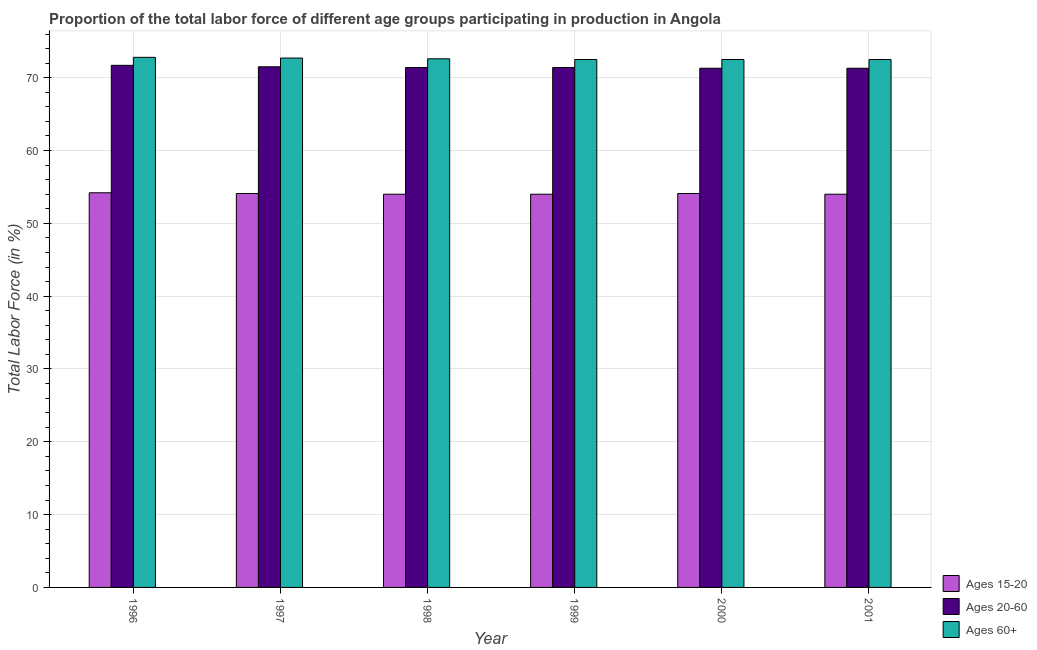How many groups of bars are there?
Give a very brief answer. 6. Are the number of bars per tick equal to the number of legend labels?
Your response must be concise. Yes. Are the number of bars on each tick of the X-axis equal?
Make the answer very short. Yes. How many bars are there on the 4th tick from the right?
Your response must be concise. 3. In how many cases, is the number of bars for a given year not equal to the number of legend labels?
Ensure brevity in your answer.  0. Across all years, what is the maximum percentage of labor force within the age group 15-20?
Offer a terse response. 54.2. Across all years, what is the minimum percentage of labor force within the age group 20-60?
Your answer should be very brief. 71.3. In which year was the percentage of labor force within the age group 20-60 minimum?
Offer a very short reply. 2000. What is the total percentage of labor force above age 60 in the graph?
Provide a short and direct response. 435.6. What is the difference between the percentage of labor force within the age group 15-20 in 1996 and that in 1998?
Your answer should be very brief. 0.2. What is the difference between the percentage of labor force above age 60 in 2000 and the percentage of labor force within the age group 20-60 in 1996?
Provide a short and direct response. -0.3. What is the average percentage of labor force above age 60 per year?
Provide a succinct answer. 72.6. In how many years, is the percentage of labor force within the age group 15-20 greater than 26 %?
Your answer should be compact. 6. What is the ratio of the percentage of labor force within the age group 20-60 in 1996 to that in 1997?
Offer a very short reply. 1. Is the percentage of labor force above age 60 in 1998 less than that in 2000?
Your answer should be very brief. No. Is the difference between the percentage of labor force above age 60 in 1996 and 1997 greater than the difference between the percentage of labor force within the age group 15-20 in 1996 and 1997?
Make the answer very short. No. What is the difference between the highest and the second highest percentage of labor force within the age group 20-60?
Give a very brief answer. 0.2. What is the difference between the highest and the lowest percentage of labor force within the age group 15-20?
Your answer should be compact. 0.2. In how many years, is the percentage of labor force within the age group 20-60 greater than the average percentage of labor force within the age group 20-60 taken over all years?
Offer a very short reply. 2. Is the sum of the percentage of labor force above age 60 in 1997 and 1998 greater than the maximum percentage of labor force within the age group 20-60 across all years?
Provide a short and direct response. Yes. What does the 1st bar from the left in 1999 represents?
Ensure brevity in your answer.  Ages 15-20. What does the 3rd bar from the right in 1997 represents?
Provide a short and direct response. Ages 15-20. How many bars are there?
Your answer should be compact. 18. How many years are there in the graph?
Your response must be concise. 6. Are the values on the major ticks of Y-axis written in scientific E-notation?
Offer a terse response. No. Does the graph contain grids?
Your answer should be compact. Yes. Where does the legend appear in the graph?
Provide a succinct answer. Bottom right. What is the title of the graph?
Make the answer very short. Proportion of the total labor force of different age groups participating in production in Angola. Does "Fuel" appear as one of the legend labels in the graph?
Your answer should be very brief. No. What is the Total Labor Force (in %) in Ages 15-20 in 1996?
Make the answer very short. 54.2. What is the Total Labor Force (in %) of Ages 20-60 in 1996?
Your response must be concise. 71.7. What is the Total Labor Force (in %) of Ages 60+ in 1996?
Keep it short and to the point. 72.8. What is the Total Labor Force (in %) of Ages 15-20 in 1997?
Your answer should be very brief. 54.1. What is the Total Labor Force (in %) in Ages 20-60 in 1997?
Offer a very short reply. 71.5. What is the Total Labor Force (in %) of Ages 60+ in 1997?
Provide a succinct answer. 72.7. What is the Total Labor Force (in %) of Ages 15-20 in 1998?
Provide a short and direct response. 54. What is the Total Labor Force (in %) of Ages 20-60 in 1998?
Your answer should be compact. 71.4. What is the Total Labor Force (in %) in Ages 60+ in 1998?
Provide a succinct answer. 72.6. What is the Total Labor Force (in %) of Ages 15-20 in 1999?
Ensure brevity in your answer.  54. What is the Total Labor Force (in %) in Ages 20-60 in 1999?
Keep it short and to the point. 71.4. What is the Total Labor Force (in %) of Ages 60+ in 1999?
Your response must be concise. 72.5. What is the Total Labor Force (in %) of Ages 15-20 in 2000?
Give a very brief answer. 54.1. What is the Total Labor Force (in %) in Ages 20-60 in 2000?
Ensure brevity in your answer.  71.3. What is the Total Labor Force (in %) in Ages 60+ in 2000?
Your answer should be compact. 72.5. What is the Total Labor Force (in %) of Ages 20-60 in 2001?
Provide a succinct answer. 71.3. What is the Total Labor Force (in %) in Ages 60+ in 2001?
Provide a succinct answer. 72.5. Across all years, what is the maximum Total Labor Force (in %) in Ages 15-20?
Give a very brief answer. 54.2. Across all years, what is the maximum Total Labor Force (in %) of Ages 20-60?
Offer a very short reply. 71.7. Across all years, what is the maximum Total Labor Force (in %) in Ages 60+?
Keep it short and to the point. 72.8. Across all years, what is the minimum Total Labor Force (in %) of Ages 15-20?
Offer a very short reply. 54. Across all years, what is the minimum Total Labor Force (in %) in Ages 20-60?
Your answer should be compact. 71.3. Across all years, what is the minimum Total Labor Force (in %) in Ages 60+?
Ensure brevity in your answer.  72.5. What is the total Total Labor Force (in %) of Ages 15-20 in the graph?
Ensure brevity in your answer.  324.4. What is the total Total Labor Force (in %) in Ages 20-60 in the graph?
Your answer should be very brief. 428.6. What is the total Total Labor Force (in %) in Ages 60+ in the graph?
Your response must be concise. 435.6. What is the difference between the Total Labor Force (in %) of Ages 15-20 in 1996 and that in 1997?
Your answer should be very brief. 0.1. What is the difference between the Total Labor Force (in %) of Ages 20-60 in 1996 and that in 1997?
Your response must be concise. 0.2. What is the difference between the Total Labor Force (in %) in Ages 15-20 in 1996 and that in 1998?
Ensure brevity in your answer.  0.2. What is the difference between the Total Labor Force (in %) of Ages 20-60 in 1996 and that in 1998?
Offer a terse response. 0.3. What is the difference between the Total Labor Force (in %) of Ages 20-60 in 1996 and that in 1999?
Offer a very short reply. 0.3. What is the difference between the Total Labor Force (in %) of Ages 60+ in 1996 and that in 1999?
Provide a succinct answer. 0.3. What is the difference between the Total Labor Force (in %) of Ages 15-20 in 1996 and that in 2000?
Make the answer very short. 0.1. What is the difference between the Total Labor Force (in %) in Ages 15-20 in 1996 and that in 2001?
Provide a succinct answer. 0.2. What is the difference between the Total Labor Force (in %) in Ages 20-60 in 1996 and that in 2001?
Make the answer very short. 0.4. What is the difference between the Total Labor Force (in %) of Ages 60+ in 1996 and that in 2001?
Provide a short and direct response. 0.3. What is the difference between the Total Labor Force (in %) of Ages 20-60 in 1997 and that in 1998?
Your response must be concise. 0.1. What is the difference between the Total Labor Force (in %) of Ages 20-60 in 1997 and that in 1999?
Give a very brief answer. 0.1. What is the difference between the Total Labor Force (in %) in Ages 20-60 in 1997 and that in 2001?
Provide a short and direct response. 0.2. What is the difference between the Total Labor Force (in %) of Ages 60+ in 1997 and that in 2001?
Offer a terse response. 0.2. What is the difference between the Total Labor Force (in %) in Ages 60+ in 1998 and that in 1999?
Provide a short and direct response. 0.1. What is the difference between the Total Labor Force (in %) of Ages 20-60 in 1998 and that in 2000?
Keep it short and to the point. 0.1. What is the difference between the Total Labor Force (in %) of Ages 20-60 in 1998 and that in 2001?
Your answer should be compact. 0.1. What is the difference between the Total Labor Force (in %) of Ages 15-20 in 1999 and that in 2000?
Give a very brief answer. -0.1. What is the difference between the Total Labor Force (in %) of Ages 20-60 in 1999 and that in 2000?
Give a very brief answer. 0.1. What is the difference between the Total Labor Force (in %) of Ages 60+ in 1999 and that in 2000?
Offer a very short reply. 0. What is the difference between the Total Labor Force (in %) of Ages 60+ in 2000 and that in 2001?
Offer a terse response. 0. What is the difference between the Total Labor Force (in %) in Ages 15-20 in 1996 and the Total Labor Force (in %) in Ages 20-60 in 1997?
Provide a short and direct response. -17.3. What is the difference between the Total Labor Force (in %) in Ages 15-20 in 1996 and the Total Labor Force (in %) in Ages 60+ in 1997?
Give a very brief answer. -18.5. What is the difference between the Total Labor Force (in %) of Ages 20-60 in 1996 and the Total Labor Force (in %) of Ages 60+ in 1997?
Keep it short and to the point. -1. What is the difference between the Total Labor Force (in %) of Ages 15-20 in 1996 and the Total Labor Force (in %) of Ages 20-60 in 1998?
Offer a terse response. -17.2. What is the difference between the Total Labor Force (in %) in Ages 15-20 in 1996 and the Total Labor Force (in %) in Ages 60+ in 1998?
Offer a very short reply. -18.4. What is the difference between the Total Labor Force (in %) in Ages 15-20 in 1996 and the Total Labor Force (in %) in Ages 20-60 in 1999?
Provide a succinct answer. -17.2. What is the difference between the Total Labor Force (in %) in Ages 15-20 in 1996 and the Total Labor Force (in %) in Ages 60+ in 1999?
Provide a short and direct response. -18.3. What is the difference between the Total Labor Force (in %) of Ages 15-20 in 1996 and the Total Labor Force (in %) of Ages 20-60 in 2000?
Offer a very short reply. -17.1. What is the difference between the Total Labor Force (in %) in Ages 15-20 in 1996 and the Total Labor Force (in %) in Ages 60+ in 2000?
Ensure brevity in your answer.  -18.3. What is the difference between the Total Labor Force (in %) of Ages 20-60 in 1996 and the Total Labor Force (in %) of Ages 60+ in 2000?
Offer a terse response. -0.8. What is the difference between the Total Labor Force (in %) in Ages 15-20 in 1996 and the Total Labor Force (in %) in Ages 20-60 in 2001?
Offer a terse response. -17.1. What is the difference between the Total Labor Force (in %) in Ages 15-20 in 1996 and the Total Labor Force (in %) in Ages 60+ in 2001?
Your answer should be compact. -18.3. What is the difference between the Total Labor Force (in %) in Ages 20-60 in 1996 and the Total Labor Force (in %) in Ages 60+ in 2001?
Your response must be concise. -0.8. What is the difference between the Total Labor Force (in %) of Ages 15-20 in 1997 and the Total Labor Force (in %) of Ages 20-60 in 1998?
Make the answer very short. -17.3. What is the difference between the Total Labor Force (in %) of Ages 15-20 in 1997 and the Total Labor Force (in %) of Ages 60+ in 1998?
Provide a short and direct response. -18.5. What is the difference between the Total Labor Force (in %) of Ages 15-20 in 1997 and the Total Labor Force (in %) of Ages 20-60 in 1999?
Offer a terse response. -17.3. What is the difference between the Total Labor Force (in %) of Ages 15-20 in 1997 and the Total Labor Force (in %) of Ages 60+ in 1999?
Keep it short and to the point. -18.4. What is the difference between the Total Labor Force (in %) in Ages 20-60 in 1997 and the Total Labor Force (in %) in Ages 60+ in 1999?
Your answer should be compact. -1. What is the difference between the Total Labor Force (in %) of Ages 15-20 in 1997 and the Total Labor Force (in %) of Ages 20-60 in 2000?
Make the answer very short. -17.2. What is the difference between the Total Labor Force (in %) in Ages 15-20 in 1997 and the Total Labor Force (in %) in Ages 60+ in 2000?
Your response must be concise. -18.4. What is the difference between the Total Labor Force (in %) in Ages 20-60 in 1997 and the Total Labor Force (in %) in Ages 60+ in 2000?
Your response must be concise. -1. What is the difference between the Total Labor Force (in %) in Ages 15-20 in 1997 and the Total Labor Force (in %) in Ages 20-60 in 2001?
Give a very brief answer. -17.2. What is the difference between the Total Labor Force (in %) in Ages 15-20 in 1997 and the Total Labor Force (in %) in Ages 60+ in 2001?
Your answer should be compact. -18.4. What is the difference between the Total Labor Force (in %) of Ages 20-60 in 1997 and the Total Labor Force (in %) of Ages 60+ in 2001?
Your answer should be compact. -1. What is the difference between the Total Labor Force (in %) of Ages 15-20 in 1998 and the Total Labor Force (in %) of Ages 20-60 in 1999?
Ensure brevity in your answer.  -17.4. What is the difference between the Total Labor Force (in %) in Ages 15-20 in 1998 and the Total Labor Force (in %) in Ages 60+ in 1999?
Your response must be concise. -18.5. What is the difference between the Total Labor Force (in %) of Ages 15-20 in 1998 and the Total Labor Force (in %) of Ages 20-60 in 2000?
Offer a terse response. -17.3. What is the difference between the Total Labor Force (in %) in Ages 15-20 in 1998 and the Total Labor Force (in %) in Ages 60+ in 2000?
Your answer should be compact. -18.5. What is the difference between the Total Labor Force (in %) of Ages 20-60 in 1998 and the Total Labor Force (in %) of Ages 60+ in 2000?
Your answer should be compact. -1.1. What is the difference between the Total Labor Force (in %) of Ages 15-20 in 1998 and the Total Labor Force (in %) of Ages 20-60 in 2001?
Your answer should be very brief. -17.3. What is the difference between the Total Labor Force (in %) of Ages 15-20 in 1998 and the Total Labor Force (in %) of Ages 60+ in 2001?
Offer a very short reply. -18.5. What is the difference between the Total Labor Force (in %) in Ages 20-60 in 1998 and the Total Labor Force (in %) in Ages 60+ in 2001?
Provide a succinct answer. -1.1. What is the difference between the Total Labor Force (in %) in Ages 15-20 in 1999 and the Total Labor Force (in %) in Ages 20-60 in 2000?
Your response must be concise. -17.3. What is the difference between the Total Labor Force (in %) in Ages 15-20 in 1999 and the Total Labor Force (in %) in Ages 60+ in 2000?
Provide a short and direct response. -18.5. What is the difference between the Total Labor Force (in %) in Ages 15-20 in 1999 and the Total Labor Force (in %) in Ages 20-60 in 2001?
Keep it short and to the point. -17.3. What is the difference between the Total Labor Force (in %) in Ages 15-20 in 1999 and the Total Labor Force (in %) in Ages 60+ in 2001?
Offer a terse response. -18.5. What is the difference between the Total Labor Force (in %) of Ages 15-20 in 2000 and the Total Labor Force (in %) of Ages 20-60 in 2001?
Offer a terse response. -17.2. What is the difference between the Total Labor Force (in %) of Ages 15-20 in 2000 and the Total Labor Force (in %) of Ages 60+ in 2001?
Offer a very short reply. -18.4. What is the difference between the Total Labor Force (in %) of Ages 20-60 in 2000 and the Total Labor Force (in %) of Ages 60+ in 2001?
Give a very brief answer. -1.2. What is the average Total Labor Force (in %) of Ages 15-20 per year?
Keep it short and to the point. 54.07. What is the average Total Labor Force (in %) of Ages 20-60 per year?
Your answer should be compact. 71.43. What is the average Total Labor Force (in %) in Ages 60+ per year?
Make the answer very short. 72.6. In the year 1996, what is the difference between the Total Labor Force (in %) in Ages 15-20 and Total Labor Force (in %) in Ages 20-60?
Provide a short and direct response. -17.5. In the year 1996, what is the difference between the Total Labor Force (in %) in Ages 15-20 and Total Labor Force (in %) in Ages 60+?
Offer a terse response. -18.6. In the year 1997, what is the difference between the Total Labor Force (in %) of Ages 15-20 and Total Labor Force (in %) of Ages 20-60?
Give a very brief answer. -17.4. In the year 1997, what is the difference between the Total Labor Force (in %) of Ages 15-20 and Total Labor Force (in %) of Ages 60+?
Your response must be concise. -18.6. In the year 1998, what is the difference between the Total Labor Force (in %) of Ages 15-20 and Total Labor Force (in %) of Ages 20-60?
Offer a very short reply. -17.4. In the year 1998, what is the difference between the Total Labor Force (in %) of Ages 15-20 and Total Labor Force (in %) of Ages 60+?
Ensure brevity in your answer.  -18.6. In the year 1999, what is the difference between the Total Labor Force (in %) of Ages 15-20 and Total Labor Force (in %) of Ages 20-60?
Your answer should be very brief. -17.4. In the year 1999, what is the difference between the Total Labor Force (in %) of Ages 15-20 and Total Labor Force (in %) of Ages 60+?
Your response must be concise. -18.5. In the year 1999, what is the difference between the Total Labor Force (in %) of Ages 20-60 and Total Labor Force (in %) of Ages 60+?
Your answer should be very brief. -1.1. In the year 2000, what is the difference between the Total Labor Force (in %) of Ages 15-20 and Total Labor Force (in %) of Ages 20-60?
Make the answer very short. -17.2. In the year 2000, what is the difference between the Total Labor Force (in %) of Ages 15-20 and Total Labor Force (in %) of Ages 60+?
Keep it short and to the point. -18.4. In the year 2000, what is the difference between the Total Labor Force (in %) of Ages 20-60 and Total Labor Force (in %) of Ages 60+?
Your answer should be compact. -1.2. In the year 2001, what is the difference between the Total Labor Force (in %) of Ages 15-20 and Total Labor Force (in %) of Ages 20-60?
Provide a short and direct response. -17.3. In the year 2001, what is the difference between the Total Labor Force (in %) of Ages 15-20 and Total Labor Force (in %) of Ages 60+?
Your answer should be compact. -18.5. In the year 2001, what is the difference between the Total Labor Force (in %) of Ages 20-60 and Total Labor Force (in %) of Ages 60+?
Provide a succinct answer. -1.2. What is the ratio of the Total Labor Force (in %) of Ages 15-20 in 1996 to that in 1997?
Your answer should be compact. 1. What is the ratio of the Total Labor Force (in %) in Ages 15-20 in 1996 to that in 1998?
Your answer should be compact. 1. What is the ratio of the Total Labor Force (in %) in Ages 20-60 in 1996 to that in 1998?
Provide a succinct answer. 1. What is the ratio of the Total Labor Force (in %) of Ages 15-20 in 1996 to that in 1999?
Keep it short and to the point. 1. What is the ratio of the Total Labor Force (in %) of Ages 60+ in 1996 to that in 1999?
Your answer should be compact. 1. What is the ratio of the Total Labor Force (in %) in Ages 15-20 in 1996 to that in 2000?
Your answer should be compact. 1. What is the ratio of the Total Labor Force (in %) of Ages 20-60 in 1996 to that in 2000?
Your answer should be very brief. 1.01. What is the ratio of the Total Labor Force (in %) in Ages 60+ in 1996 to that in 2000?
Provide a short and direct response. 1. What is the ratio of the Total Labor Force (in %) in Ages 20-60 in 1996 to that in 2001?
Offer a terse response. 1.01. What is the ratio of the Total Labor Force (in %) in Ages 60+ in 1996 to that in 2001?
Provide a succinct answer. 1. What is the ratio of the Total Labor Force (in %) of Ages 15-20 in 1997 to that in 1998?
Keep it short and to the point. 1. What is the ratio of the Total Labor Force (in %) in Ages 60+ in 1997 to that in 1998?
Your answer should be compact. 1. What is the ratio of the Total Labor Force (in %) of Ages 20-60 in 1997 to that in 2000?
Give a very brief answer. 1. What is the ratio of the Total Labor Force (in %) of Ages 60+ in 1997 to that in 2000?
Keep it short and to the point. 1. What is the ratio of the Total Labor Force (in %) in Ages 15-20 in 1997 to that in 2001?
Provide a succinct answer. 1. What is the ratio of the Total Labor Force (in %) in Ages 20-60 in 1998 to that in 1999?
Ensure brevity in your answer.  1. What is the ratio of the Total Labor Force (in %) in Ages 15-20 in 1998 to that in 2000?
Provide a short and direct response. 1. What is the ratio of the Total Labor Force (in %) of Ages 15-20 in 1999 to that in 2000?
Provide a succinct answer. 1. What is the ratio of the Total Labor Force (in %) of Ages 20-60 in 1999 to that in 2000?
Offer a terse response. 1. What is the ratio of the Total Labor Force (in %) of Ages 60+ in 1999 to that in 2001?
Make the answer very short. 1. What is the ratio of the Total Labor Force (in %) in Ages 20-60 in 2000 to that in 2001?
Provide a short and direct response. 1. What is the difference between the highest and the second highest Total Labor Force (in %) of Ages 15-20?
Ensure brevity in your answer.  0.1. What is the difference between the highest and the second highest Total Labor Force (in %) of Ages 20-60?
Your answer should be very brief. 0.2. What is the difference between the highest and the lowest Total Labor Force (in %) in Ages 15-20?
Your answer should be very brief. 0.2. What is the difference between the highest and the lowest Total Labor Force (in %) in Ages 20-60?
Provide a short and direct response. 0.4. 